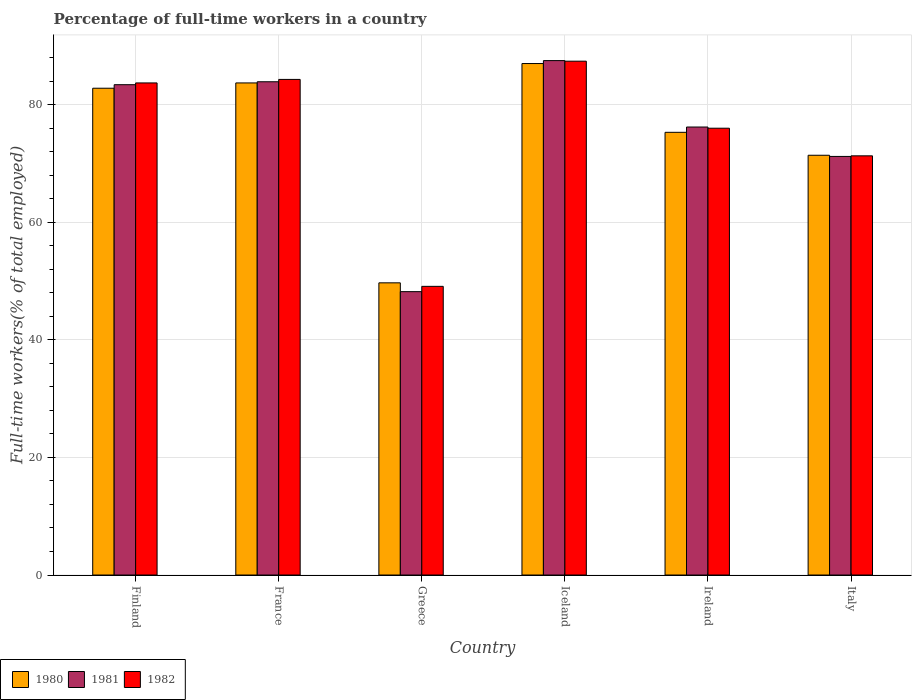How many different coloured bars are there?
Offer a terse response. 3. Are the number of bars on each tick of the X-axis equal?
Provide a succinct answer. Yes. How many bars are there on the 6th tick from the left?
Provide a short and direct response. 3. How many bars are there on the 5th tick from the right?
Offer a terse response. 3. What is the label of the 3rd group of bars from the left?
Your answer should be compact. Greece. What is the percentage of full-time workers in 1981 in Iceland?
Make the answer very short. 87.5. Across all countries, what is the maximum percentage of full-time workers in 1981?
Keep it short and to the point. 87.5. Across all countries, what is the minimum percentage of full-time workers in 1980?
Provide a succinct answer. 49.7. In which country was the percentage of full-time workers in 1982 minimum?
Your answer should be compact. Greece. What is the total percentage of full-time workers in 1982 in the graph?
Your answer should be very brief. 451.8. What is the difference between the percentage of full-time workers in 1982 in Finland and that in Italy?
Give a very brief answer. 12.4. What is the difference between the percentage of full-time workers in 1980 in Iceland and the percentage of full-time workers in 1982 in Finland?
Your response must be concise. 3.3. What is the average percentage of full-time workers in 1982 per country?
Your answer should be compact. 75.3. What is the difference between the percentage of full-time workers of/in 1982 and percentage of full-time workers of/in 1980 in Greece?
Your response must be concise. -0.6. In how many countries, is the percentage of full-time workers in 1980 greater than 48 %?
Your answer should be compact. 6. What is the ratio of the percentage of full-time workers in 1981 in Greece to that in Ireland?
Your answer should be very brief. 0.63. What is the difference between the highest and the second highest percentage of full-time workers in 1982?
Give a very brief answer. -0.6. What is the difference between the highest and the lowest percentage of full-time workers in 1980?
Keep it short and to the point. 37.3. In how many countries, is the percentage of full-time workers in 1982 greater than the average percentage of full-time workers in 1982 taken over all countries?
Offer a terse response. 4. Is the sum of the percentage of full-time workers in 1982 in Ireland and Italy greater than the maximum percentage of full-time workers in 1980 across all countries?
Give a very brief answer. Yes. What does the 2nd bar from the right in Ireland represents?
Provide a short and direct response. 1981. How many bars are there?
Provide a short and direct response. 18. Are all the bars in the graph horizontal?
Make the answer very short. No. Are the values on the major ticks of Y-axis written in scientific E-notation?
Provide a succinct answer. No. Does the graph contain any zero values?
Your answer should be compact. No. Where does the legend appear in the graph?
Your response must be concise. Bottom left. What is the title of the graph?
Keep it short and to the point. Percentage of full-time workers in a country. What is the label or title of the Y-axis?
Provide a short and direct response. Full-time workers(% of total employed). What is the Full-time workers(% of total employed) in 1980 in Finland?
Offer a very short reply. 82.8. What is the Full-time workers(% of total employed) in 1981 in Finland?
Provide a short and direct response. 83.4. What is the Full-time workers(% of total employed) of 1982 in Finland?
Offer a very short reply. 83.7. What is the Full-time workers(% of total employed) of 1980 in France?
Ensure brevity in your answer.  83.7. What is the Full-time workers(% of total employed) of 1981 in France?
Your answer should be compact. 83.9. What is the Full-time workers(% of total employed) of 1982 in France?
Provide a succinct answer. 84.3. What is the Full-time workers(% of total employed) of 1980 in Greece?
Give a very brief answer. 49.7. What is the Full-time workers(% of total employed) in 1981 in Greece?
Provide a short and direct response. 48.2. What is the Full-time workers(% of total employed) in 1982 in Greece?
Give a very brief answer. 49.1. What is the Full-time workers(% of total employed) in 1981 in Iceland?
Give a very brief answer. 87.5. What is the Full-time workers(% of total employed) of 1982 in Iceland?
Ensure brevity in your answer.  87.4. What is the Full-time workers(% of total employed) in 1980 in Ireland?
Provide a succinct answer. 75.3. What is the Full-time workers(% of total employed) of 1981 in Ireland?
Your answer should be compact. 76.2. What is the Full-time workers(% of total employed) of 1982 in Ireland?
Offer a very short reply. 76. What is the Full-time workers(% of total employed) of 1980 in Italy?
Your answer should be compact. 71.4. What is the Full-time workers(% of total employed) of 1981 in Italy?
Your answer should be very brief. 71.2. What is the Full-time workers(% of total employed) of 1982 in Italy?
Your answer should be compact. 71.3. Across all countries, what is the maximum Full-time workers(% of total employed) in 1980?
Provide a short and direct response. 87. Across all countries, what is the maximum Full-time workers(% of total employed) in 1981?
Ensure brevity in your answer.  87.5. Across all countries, what is the maximum Full-time workers(% of total employed) of 1982?
Offer a very short reply. 87.4. Across all countries, what is the minimum Full-time workers(% of total employed) in 1980?
Ensure brevity in your answer.  49.7. Across all countries, what is the minimum Full-time workers(% of total employed) of 1981?
Ensure brevity in your answer.  48.2. Across all countries, what is the minimum Full-time workers(% of total employed) of 1982?
Give a very brief answer. 49.1. What is the total Full-time workers(% of total employed) of 1980 in the graph?
Give a very brief answer. 449.9. What is the total Full-time workers(% of total employed) of 1981 in the graph?
Your answer should be very brief. 450.4. What is the total Full-time workers(% of total employed) in 1982 in the graph?
Offer a very short reply. 451.8. What is the difference between the Full-time workers(% of total employed) of 1980 in Finland and that in France?
Give a very brief answer. -0.9. What is the difference between the Full-time workers(% of total employed) in 1980 in Finland and that in Greece?
Provide a succinct answer. 33.1. What is the difference between the Full-time workers(% of total employed) in 1981 in Finland and that in Greece?
Ensure brevity in your answer.  35.2. What is the difference between the Full-time workers(% of total employed) of 1982 in Finland and that in Greece?
Ensure brevity in your answer.  34.6. What is the difference between the Full-time workers(% of total employed) of 1980 in Finland and that in Iceland?
Keep it short and to the point. -4.2. What is the difference between the Full-time workers(% of total employed) of 1980 in Finland and that in Ireland?
Give a very brief answer. 7.5. What is the difference between the Full-time workers(% of total employed) in 1981 in Finland and that in Ireland?
Offer a very short reply. 7.2. What is the difference between the Full-time workers(% of total employed) in 1980 in Finland and that in Italy?
Your answer should be very brief. 11.4. What is the difference between the Full-time workers(% of total employed) in 1981 in France and that in Greece?
Offer a very short reply. 35.7. What is the difference between the Full-time workers(% of total employed) in 1982 in France and that in Greece?
Offer a terse response. 35.2. What is the difference between the Full-time workers(% of total employed) of 1981 in France and that in Iceland?
Your answer should be compact. -3.6. What is the difference between the Full-time workers(% of total employed) in 1982 in France and that in Iceland?
Make the answer very short. -3.1. What is the difference between the Full-time workers(% of total employed) in 1980 in France and that in Ireland?
Make the answer very short. 8.4. What is the difference between the Full-time workers(% of total employed) in 1981 in France and that in Ireland?
Your answer should be very brief. 7.7. What is the difference between the Full-time workers(% of total employed) of 1980 in France and that in Italy?
Offer a very short reply. 12.3. What is the difference between the Full-time workers(% of total employed) of 1981 in France and that in Italy?
Offer a terse response. 12.7. What is the difference between the Full-time workers(% of total employed) of 1982 in France and that in Italy?
Offer a very short reply. 13. What is the difference between the Full-time workers(% of total employed) in 1980 in Greece and that in Iceland?
Your answer should be compact. -37.3. What is the difference between the Full-time workers(% of total employed) in 1981 in Greece and that in Iceland?
Your response must be concise. -39.3. What is the difference between the Full-time workers(% of total employed) of 1982 in Greece and that in Iceland?
Offer a terse response. -38.3. What is the difference between the Full-time workers(% of total employed) of 1980 in Greece and that in Ireland?
Ensure brevity in your answer.  -25.6. What is the difference between the Full-time workers(% of total employed) in 1982 in Greece and that in Ireland?
Offer a terse response. -26.9. What is the difference between the Full-time workers(% of total employed) in 1980 in Greece and that in Italy?
Ensure brevity in your answer.  -21.7. What is the difference between the Full-time workers(% of total employed) in 1982 in Greece and that in Italy?
Offer a terse response. -22.2. What is the difference between the Full-time workers(% of total employed) of 1980 in Iceland and that in Ireland?
Your answer should be compact. 11.7. What is the difference between the Full-time workers(% of total employed) in 1981 in Iceland and that in Italy?
Offer a terse response. 16.3. What is the difference between the Full-time workers(% of total employed) in 1982 in Iceland and that in Italy?
Keep it short and to the point. 16.1. What is the difference between the Full-time workers(% of total employed) of 1981 in Ireland and that in Italy?
Give a very brief answer. 5. What is the difference between the Full-time workers(% of total employed) of 1982 in Ireland and that in Italy?
Give a very brief answer. 4.7. What is the difference between the Full-time workers(% of total employed) of 1980 in Finland and the Full-time workers(% of total employed) of 1981 in France?
Your answer should be compact. -1.1. What is the difference between the Full-time workers(% of total employed) in 1981 in Finland and the Full-time workers(% of total employed) in 1982 in France?
Make the answer very short. -0.9. What is the difference between the Full-time workers(% of total employed) in 1980 in Finland and the Full-time workers(% of total employed) in 1981 in Greece?
Provide a succinct answer. 34.6. What is the difference between the Full-time workers(% of total employed) of 1980 in Finland and the Full-time workers(% of total employed) of 1982 in Greece?
Ensure brevity in your answer.  33.7. What is the difference between the Full-time workers(% of total employed) in 1981 in Finland and the Full-time workers(% of total employed) in 1982 in Greece?
Your response must be concise. 34.3. What is the difference between the Full-time workers(% of total employed) of 1980 in Finland and the Full-time workers(% of total employed) of 1981 in Iceland?
Keep it short and to the point. -4.7. What is the difference between the Full-time workers(% of total employed) in 1981 in Finland and the Full-time workers(% of total employed) in 1982 in Iceland?
Your response must be concise. -4. What is the difference between the Full-time workers(% of total employed) of 1980 in Finland and the Full-time workers(% of total employed) of 1982 in Ireland?
Make the answer very short. 6.8. What is the difference between the Full-time workers(% of total employed) of 1980 in Finland and the Full-time workers(% of total employed) of 1982 in Italy?
Provide a short and direct response. 11.5. What is the difference between the Full-time workers(% of total employed) in 1980 in France and the Full-time workers(% of total employed) in 1981 in Greece?
Provide a short and direct response. 35.5. What is the difference between the Full-time workers(% of total employed) of 1980 in France and the Full-time workers(% of total employed) of 1982 in Greece?
Your response must be concise. 34.6. What is the difference between the Full-time workers(% of total employed) in 1981 in France and the Full-time workers(% of total employed) in 1982 in Greece?
Provide a succinct answer. 34.8. What is the difference between the Full-time workers(% of total employed) in 1980 in France and the Full-time workers(% of total employed) in 1982 in Iceland?
Make the answer very short. -3.7. What is the difference between the Full-time workers(% of total employed) of 1981 in France and the Full-time workers(% of total employed) of 1982 in Iceland?
Your answer should be compact. -3.5. What is the difference between the Full-time workers(% of total employed) in 1980 in France and the Full-time workers(% of total employed) in 1982 in Ireland?
Offer a terse response. 7.7. What is the difference between the Full-time workers(% of total employed) in 1980 in France and the Full-time workers(% of total employed) in 1981 in Italy?
Offer a terse response. 12.5. What is the difference between the Full-time workers(% of total employed) in 1981 in France and the Full-time workers(% of total employed) in 1982 in Italy?
Make the answer very short. 12.6. What is the difference between the Full-time workers(% of total employed) of 1980 in Greece and the Full-time workers(% of total employed) of 1981 in Iceland?
Your answer should be very brief. -37.8. What is the difference between the Full-time workers(% of total employed) of 1980 in Greece and the Full-time workers(% of total employed) of 1982 in Iceland?
Offer a very short reply. -37.7. What is the difference between the Full-time workers(% of total employed) of 1981 in Greece and the Full-time workers(% of total employed) of 1982 in Iceland?
Make the answer very short. -39.2. What is the difference between the Full-time workers(% of total employed) of 1980 in Greece and the Full-time workers(% of total employed) of 1981 in Ireland?
Give a very brief answer. -26.5. What is the difference between the Full-time workers(% of total employed) of 1980 in Greece and the Full-time workers(% of total employed) of 1982 in Ireland?
Give a very brief answer. -26.3. What is the difference between the Full-time workers(% of total employed) of 1981 in Greece and the Full-time workers(% of total employed) of 1982 in Ireland?
Provide a short and direct response. -27.8. What is the difference between the Full-time workers(% of total employed) in 1980 in Greece and the Full-time workers(% of total employed) in 1981 in Italy?
Keep it short and to the point. -21.5. What is the difference between the Full-time workers(% of total employed) of 1980 in Greece and the Full-time workers(% of total employed) of 1982 in Italy?
Offer a very short reply. -21.6. What is the difference between the Full-time workers(% of total employed) in 1981 in Greece and the Full-time workers(% of total employed) in 1982 in Italy?
Your answer should be very brief. -23.1. What is the difference between the Full-time workers(% of total employed) in 1981 in Iceland and the Full-time workers(% of total employed) in 1982 in Ireland?
Make the answer very short. 11.5. What is the difference between the Full-time workers(% of total employed) in 1980 in Iceland and the Full-time workers(% of total employed) in 1981 in Italy?
Your response must be concise. 15.8. What is the difference between the Full-time workers(% of total employed) in 1980 in Ireland and the Full-time workers(% of total employed) in 1982 in Italy?
Offer a terse response. 4. What is the difference between the Full-time workers(% of total employed) in 1981 in Ireland and the Full-time workers(% of total employed) in 1982 in Italy?
Your response must be concise. 4.9. What is the average Full-time workers(% of total employed) of 1980 per country?
Provide a short and direct response. 74.98. What is the average Full-time workers(% of total employed) in 1981 per country?
Offer a very short reply. 75.07. What is the average Full-time workers(% of total employed) of 1982 per country?
Provide a succinct answer. 75.3. What is the difference between the Full-time workers(% of total employed) in 1980 and Full-time workers(% of total employed) in 1981 in Finland?
Make the answer very short. -0.6. What is the difference between the Full-time workers(% of total employed) of 1981 and Full-time workers(% of total employed) of 1982 in Finland?
Offer a terse response. -0.3. What is the difference between the Full-time workers(% of total employed) in 1980 and Full-time workers(% of total employed) in 1981 in France?
Provide a short and direct response. -0.2. What is the difference between the Full-time workers(% of total employed) of 1980 and Full-time workers(% of total employed) of 1982 in France?
Give a very brief answer. -0.6. What is the difference between the Full-time workers(% of total employed) in 1981 and Full-time workers(% of total employed) in 1982 in France?
Your answer should be compact. -0.4. What is the difference between the Full-time workers(% of total employed) of 1980 and Full-time workers(% of total employed) of 1981 in Iceland?
Provide a succinct answer. -0.5. What is the difference between the Full-time workers(% of total employed) in 1980 and Full-time workers(% of total employed) in 1982 in Iceland?
Make the answer very short. -0.4. What is the difference between the Full-time workers(% of total employed) of 1981 and Full-time workers(% of total employed) of 1982 in Iceland?
Provide a succinct answer. 0.1. What is the difference between the Full-time workers(% of total employed) in 1980 and Full-time workers(% of total employed) in 1982 in Italy?
Offer a terse response. 0.1. What is the ratio of the Full-time workers(% of total employed) of 1980 in Finland to that in France?
Give a very brief answer. 0.99. What is the ratio of the Full-time workers(% of total employed) in 1980 in Finland to that in Greece?
Your answer should be compact. 1.67. What is the ratio of the Full-time workers(% of total employed) of 1981 in Finland to that in Greece?
Your answer should be very brief. 1.73. What is the ratio of the Full-time workers(% of total employed) of 1982 in Finland to that in Greece?
Provide a short and direct response. 1.7. What is the ratio of the Full-time workers(% of total employed) in 1980 in Finland to that in Iceland?
Keep it short and to the point. 0.95. What is the ratio of the Full-time workers(% of total employed) in 1981 in Finland to that in Iceland?
Your answer should be very brief. 0.95. What is the ratio of the Full-time workers(% of total employed) of 1982 in Finland to that in Iceland?
Provide a short and direct response. 0.96. What is the ratio of the Full-time workers(% of total employed) in 1980 in Finland to that in Ireland?
Offer a very short reply. 1.1. What is the ratio of the Full-time workers(% of total employed) in 1981 in Finland to that in Ireland?
Provide a succinct answer. 1.09. What is the ratio of the Full-time workers(% of total employed) of 1982 in Finland to that in Ireland?
Your answer should be compact. 1.1. What is the ratio of the Full-time workers(% of total employed) of 1980 in Finland to that in Italy?
Offer a terse response. 1.16. What is the ratio of the Full-time workers(% of total employed) of 1981 in Finland to that in Italy?
Your response must be concise. 1.17. What is the ratio of the Full-time workers(% of total employed) in 1982 in Finland to that in Italy?
Offer a very short reply. 1.17. What is the ratio of the Full-time workers(% of total employed) of 1980 in France to that in Greece?
Provide a succinct answer. 1.68. What is the ratio of the Full-time workers(% of total employed) in 1981 in France to that in Greece?
Give a very brief answer. 1.74. What is the ratio of the Full-time workers(% of total employed) in 1982 in France to that in Greece?
Provide a succinct answer. 1.72. What is the ratio of the Full-time workers(% of total employed) in 1980 in France to that in Iceland?
Your answer should be compact. 0.96. What is the ratio of the Full-time workers(% of total employed) in 1981 in France to that in Iceland?
Ensure brevity in your answer.  0.96. What is the ratio of the Full-time workers(% of total employed) of 1982 in France to that in Iceland?
Your answer should be very brief. 0.96. What is the ratio of the Full-time workers(% of total employed) of 1980 in France to that in Ireland?
Give a very brief answer. 1.11. What is the ratio of the Full-time workers(% of total employed) in 1981 in France to that in Ireland?
Provide a short and direct response. 1.1. What is the ratio of the Full-time workers(% of total employed) in 1982 in France to that in Ireland?
Your response must be concise. 1.11. What is the ratio of the Full-time workers(% of total employed) of 1980 in France to that in Italy?
Keep it short and to the point. 1.17. What is the ratio of the Full-time workers(% of total employed) in 1981 in France to that in Italy?
Your response must be concise. 1.18. What is the ratio of the Full-time workers(% of total employed) of 1982 in France to that in Italy?
Provide a succinct answer. 1.18. What is the ratio of the Full-time workers(% of total employed) of 1980 in Greece to that in Iceland?
Provide a succinct answer. 0.57. What is the ratio of the Full-time workers(% of total employed) of 1981 in Greece to that in Iceland?
Keep it short and to the point. 0.55. What is the ratio of the Full-time workers(% of total employed) in 1982 in Greece to that in Iceland?
Offer a terse response. 0.56. What is the ratio of the Full-time workers(% of total employed) of 1980 in Greece to that in Ireland?
Provide a short and direct response. 0.66. What is the ratio of the Full-time workers(% of total employed) in 1981 in Greece to that in Ireland?
Make the answer very short. 0.63. What is the ratio of the Full-time workers(% of total employed) in 1982 in Greece to that in Ireland?
Your answer should be very brief. 0.65. What is the ratio of the Full-time workers(% of total employed) in 1980 in Greece to that in Italy?
Your response must be concise. 0.7. What is the ratio of the Full-time workers(% of total employed) in 1981 in Greece to that in Italy?
Provide a short and direct response. 0.68. What is the ratio of the Full-time workers(% of total employed) in 1982 in Greece to that in Italy?
Provide a succinct answer. 0.69. What is the ratio of the Full-time workers(% of total employed) of 1980 in Iceland to that in Ireland?
Your answer should be very brief. 1.16. What is the ratio of the Full-time workers(% of total employed) of 1981 in Iceland to that in Ireland?
Offer a very short reply. 1.15. What is the ratio of the Full-time workers(% of total employed) of 1982 in Iceland to that in Ireland?
Provide a succinct answer. 1.15. What is the ratio of the Full-time workers(% of total employed) in 1980 in Iceland to that in Italy?
Your answer should be compact. 1.22. What is the ratio of the Full-time workers(% of total employed) in 1981 in Iceland to that in Italy?
Offer a very short reply. 1.23. What is the ratio of the Full-time workers(% of total employed) of 1982 in Iceland to that in Italy?
Keep it short and to the point. 1.23. What is the ratio of the Full-time workers(% of total employed) in 1980 in Ireland to that in Italy?
Ensure brevity in your answer.  1.05. What is the ratio of the Full-time workers(% of total employed) in 1981 in Ireland to that in Italy?
Your response must be concise. 1.07. What is the ratio of the Full-time workers(% of total employed) in 1982 in Ireland to that in Italy?
Your answer should be compact. 1.07. What is the difference between the highest and the second highest Full-time workers(% of total employed) in 1981?
Give a very brief answer. 3.6. What is the difference between the highest and the lowest Full-time workers(% of total employed) of 1980?
Give a very brief answer. 37.3. What is the difference between the highest and the lowest Full-time workers(% of total employed) in 1981?
Your response must be concise. 39.3. What is the difference between the highest and the lowest Full-time workers(% of total employed) of 1982?
Your answer should be very brief. 38.3. 